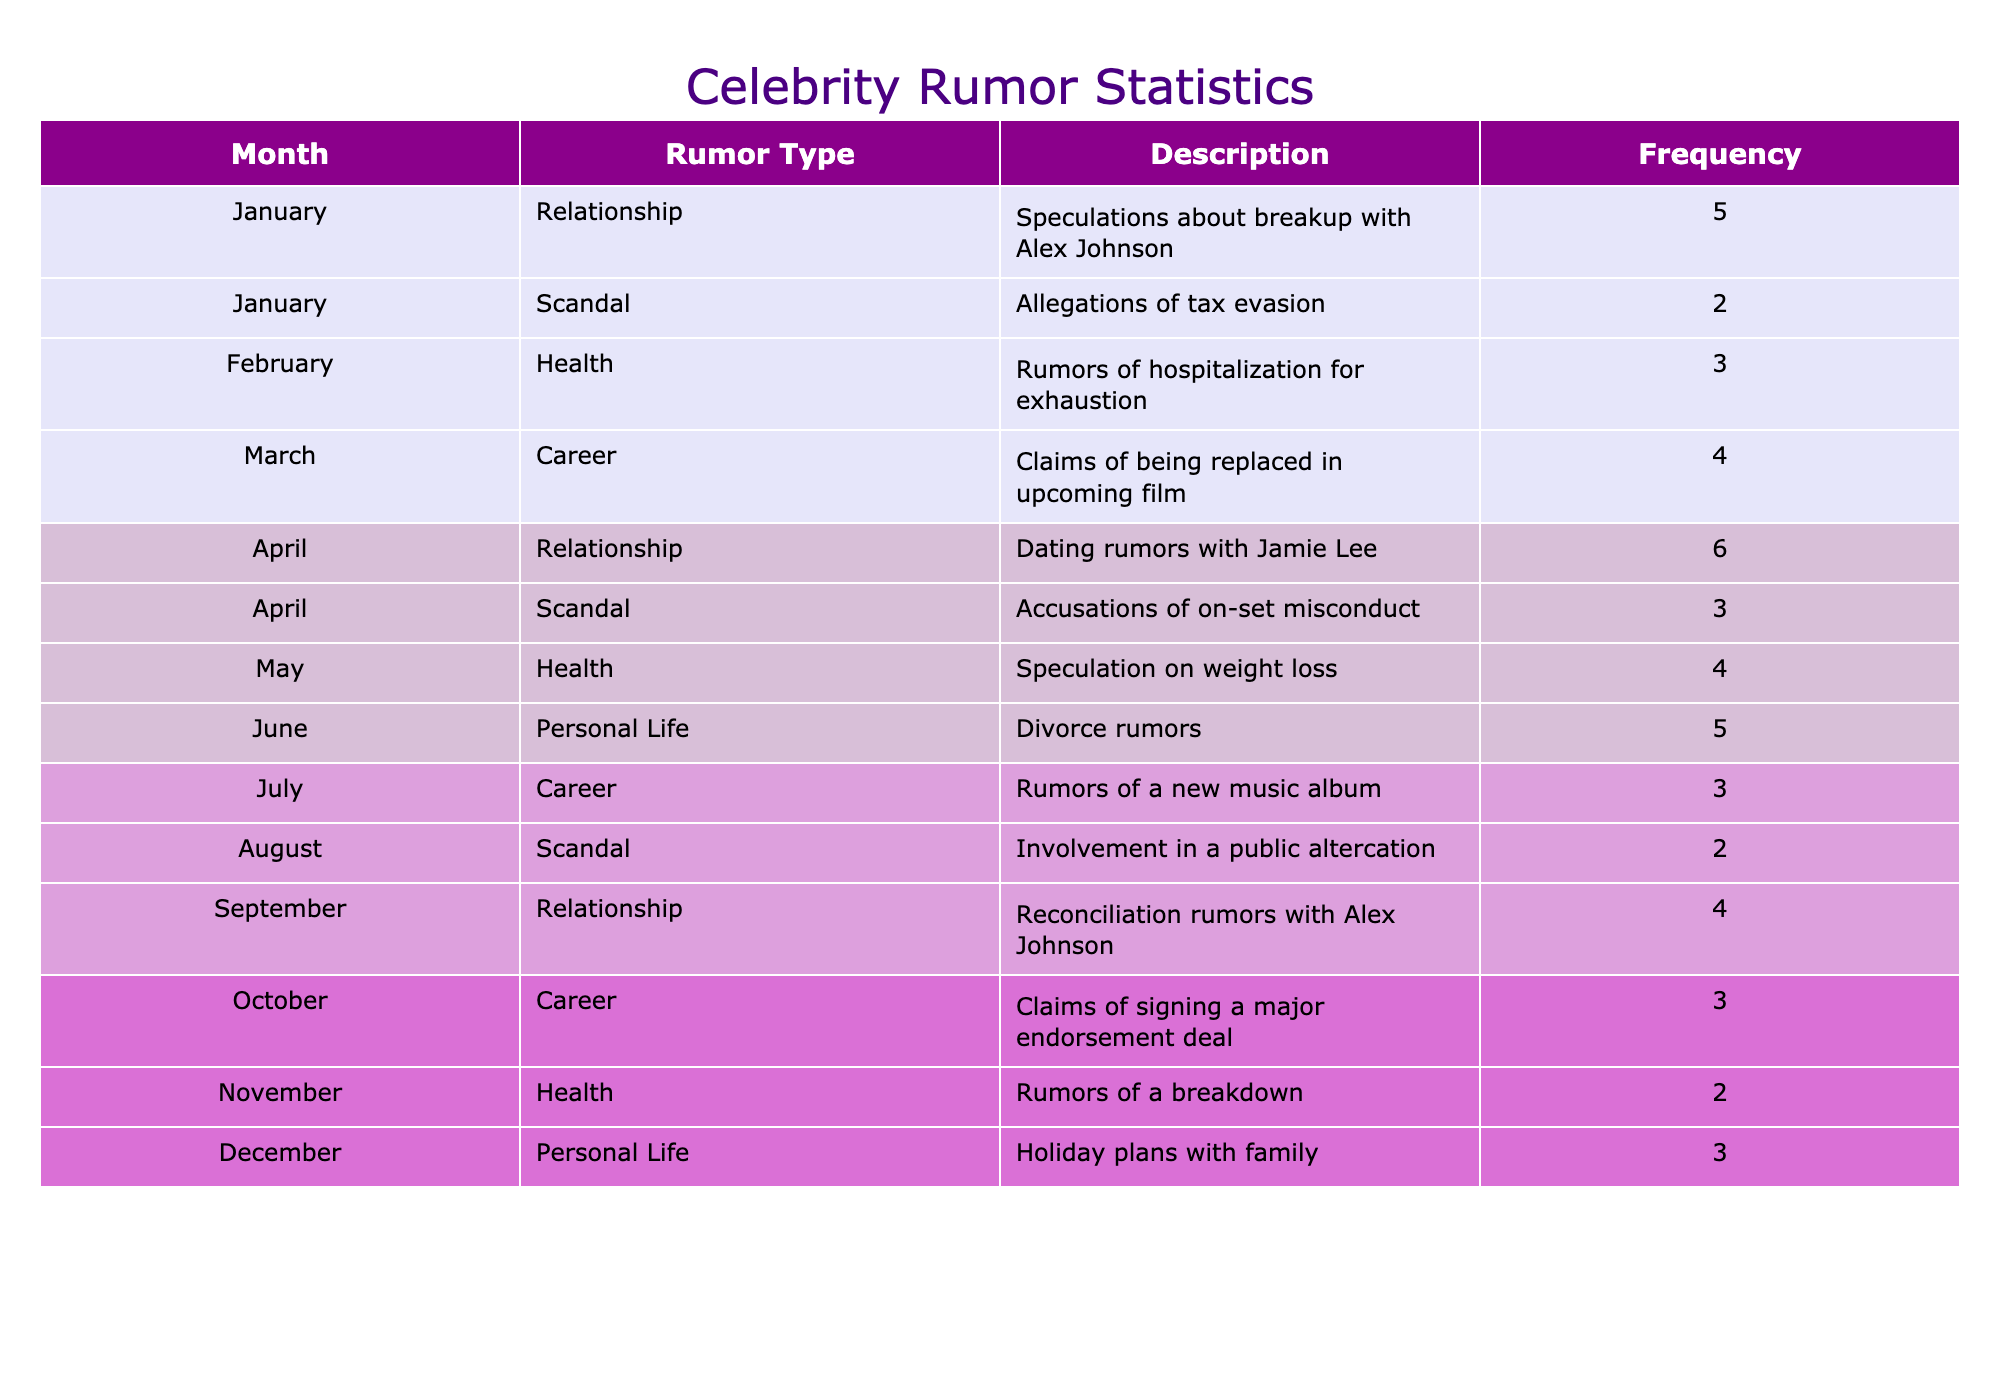What rumor type had the highest frequency in January? In January, the rumor types are Relationship with a frequency of 5, and Scandal with a frequency of 2. The highest frequency is 5, from the Relationship rumors.
Answer: Relationship How many total rumors were reported in June? In June, there are two rumors: Divorce rumors with a frequency of 5. The total is therefore just 5.
Answer: 5 What month had more accusations, April or August? In April, there are two accusations: Dating rumors with a frequency of 6 and Accusations of on-set misconduct with a frequency of 3, totaling 9. In August, there is one accusation: Involvement in a public altercation with a frequency of 2. Therefore, April had more accusations.
Answer: April Is there a rumor about a breakdown in November? The table states there are rumors of a breakdown in November with a frequency of 2. Therefore, yes, it is true.
Answer: Yes What is the average frequency of relationship rumors over the year? There are four months with relationship rumors: January (5), April (6), June (5), and September (4). The total frequency for relationships is 5 + 6 + 5 + 4 = 20. There are 4 data points. The average frequency is 20/4 = 5.
Answer: 5 Which month had the most diverse rumor types reported, and how many were there? By looking across the months, April had two rumor types (Relationship and Scandal), while others like January had fewer diverse types. April's total frequency was 9 from its two rumor types, indicating it is the most diverse.
Answer: April, 2 types How many rumors were reported in the second half of the year compared to the first half? In the first half: January (7), February (3), March (4), April (9), May (4), June (5) totaling 32. In the second half: July (3), August (2), September (4), October (3), November (2), December (3) totaling 17. Thus, the first half had more rumors than the second half.
Answer: First half had more What was the total number of Health-related rumors throughout the year? There are Health-related rumors in February (3), May (4), and November (2). Adding them gives 3 + 4 + 2 = 9.
Answer: 9 In which month did rumors of a new music album appear? The rumors of a new music album were reported in July with a frequency of 3.
Answer: July 